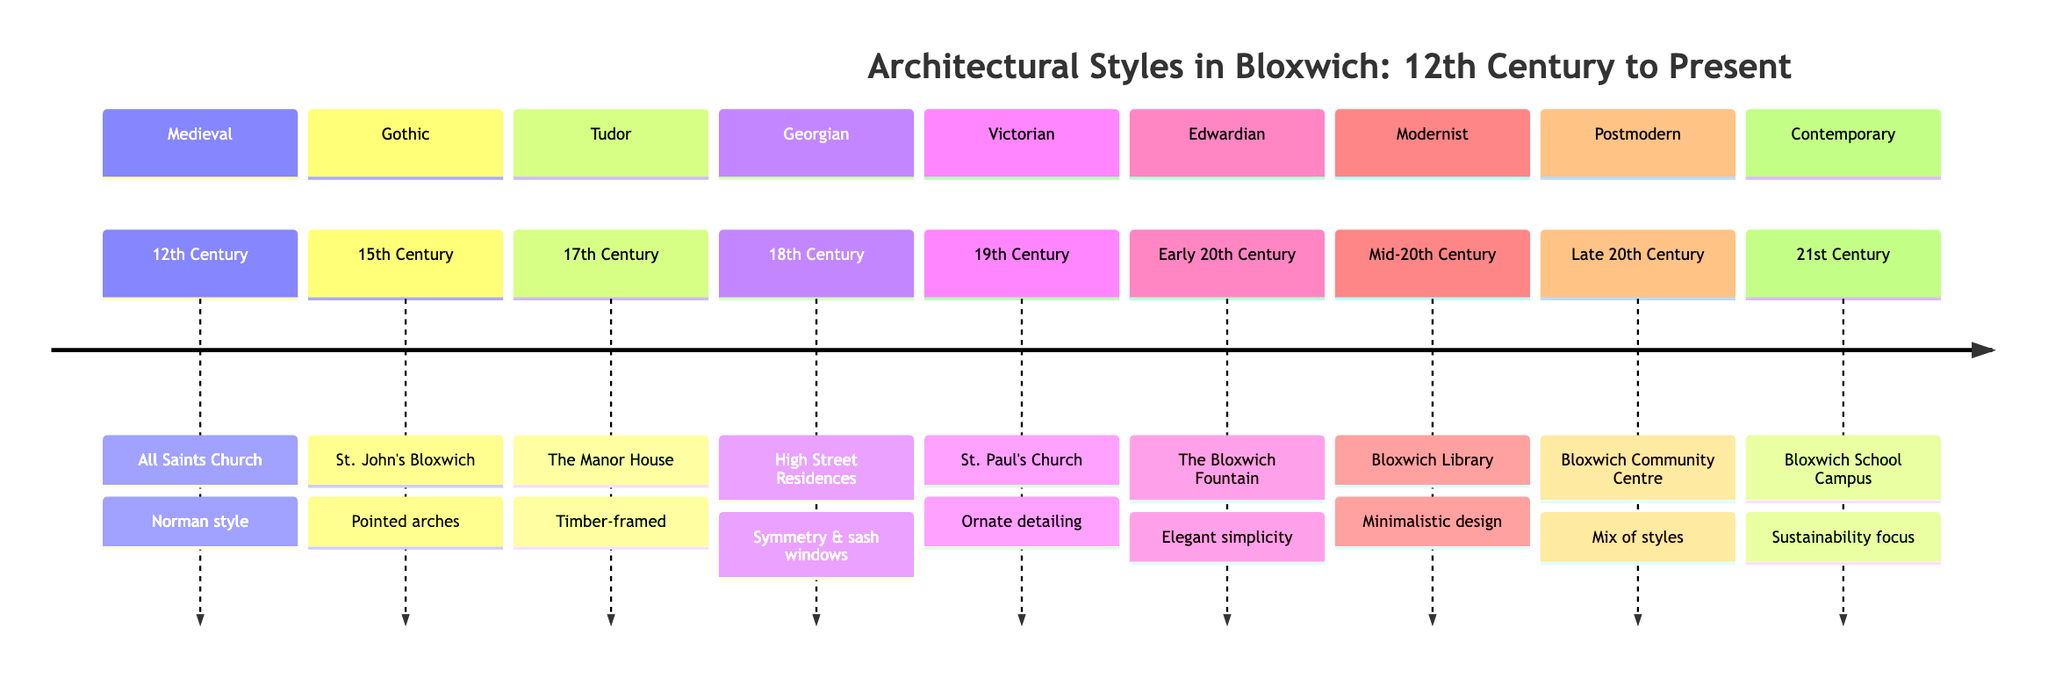What architectural style is associated with the 12th Century? The diagram shows that the architectural style associated with the 12th Century is "Medieval," as indicated next to the period.
Answer: Medieval Which building represents the Gothic style? According to the diagram, "St. John's Bloxwich" is the example given for the Gothic style in the 15th Century.
Answer: St. John's Bloxwich How many architectural styles are listed in the timeline? By counting each section, we find that there are 9 distinct architectural styles listed in the timeline.
Answer: 9 What is the defining feature of Tudor architecture? The timeline specifies that Tudor architecture is characterized by "timber-framed structures," making this the defining feature of this style.
Answer: Timber-framed structures Which century features both Georgian and Victorian styles? The timeline indicates that the 19th Century contains the Victorian style, while the 18th Century features the Georgian style, meaning these two styles are apart, and only the 19th Century includes Victorian.
Answer: N/A (no overlap) Which building was designed in the Modernist style? From the timeline, we see that "Bloxwich Library" is noted as the example of Modernist design, reflecting its characteristics.
Answer: Bloxwich Library How does the Bloxwich Community Centre incorporate historical styles? The timeline description for the Bloxwich Community Centre states it involves a "mix of new and historical styles," addressing the integration of various styles.
Answer: Mix of new and historical styles What specific architectural feature is emphasized in the 21st Century? The timeline indicates that the contemporary architectural style emphasizes "sustainability," which is a key focus in this period.
Answer: Sustainability Which style is known for its pointed arches? The Gothic style, represented by "St. John's Bloxwich," is known for its pointed arches, as directly stated in the timeline.
Answer: Pointed arches 